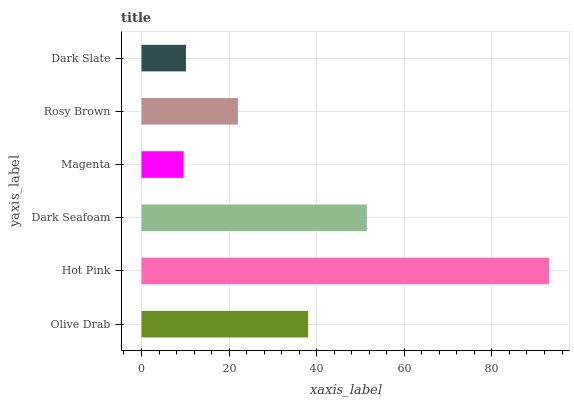Is Magenta the minimum?
Answer yes or no. Yes. Is Hot Pink the maximum?
Answer yes or no. Yes. Is Dark Seafoam the minimum?
Answer yes or no. No. Is Dark Seafoam the maximum?
Answer yes or no. No. Is Hot Pink greater than Dark Seafoam?
Answer yes or no. Yes. Is Dark Seafoam less than Hot Pink?
Answer yes or no. Yes. Is Dark Seafoam greater than Hot Pink?
Answer yes or no. No. Is Hot Pink less than Dark Seafoam?
Answer yes or no. No. Is Olive Drab the high median?
Answer yes or no. Yes. Is Rosy Brown the low median?
Answer yes or no. Yes. Is Dark Seafoam the high median?
Answer yes or no. No. Is Dark Seafoam the low median?
Answer yes or no. No. 